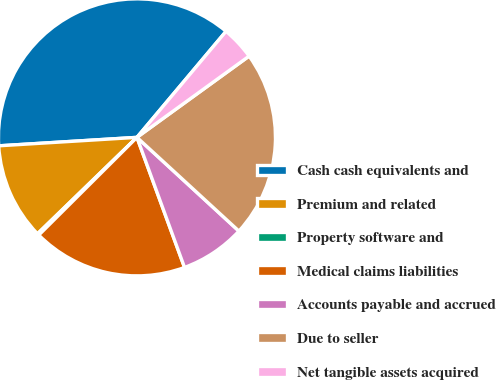<chart> <loc_0><loc_0><loc_500><loc_500><pie_chart><fcel>Cash cash equivalents and<fcel>Premium and related<fcel>Property software and<fcel>Medical claims liabilities<fcel>Accounts payable and accrued<fcel>Due to seller<fcel>Net tangible assets acquired<nl><fcel>37.1%<fcel>11.28%<fcel>0.21%<fcel>18.12%<fcel>7.59%<fcel>21.81%<fcel>3.9%<nl></chart> 